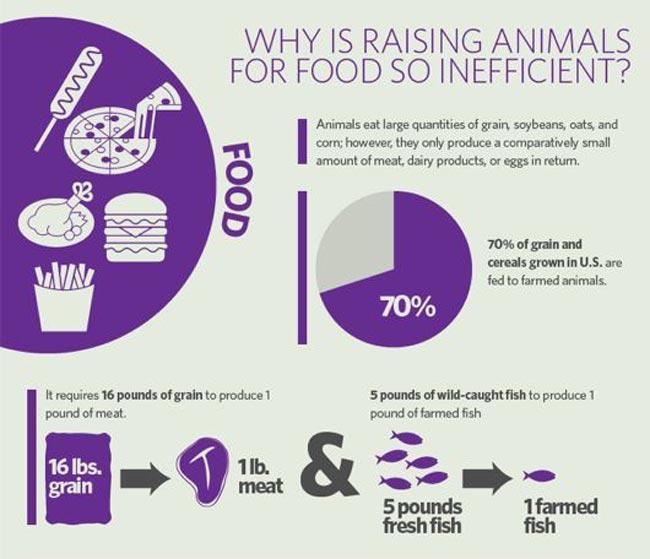Give some essential details in this illustration. To produce 1 pound of meat, 16, 5, or 7.25 kilograms of grain are required, with 7.25 kilograms producing the highest amount of meat. 